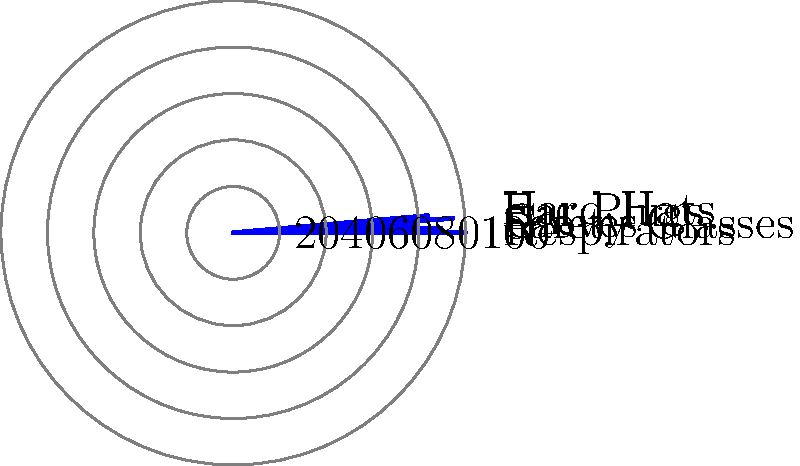Based on the polar bar chart depicting the effectiveness of various personal protective equipment (PPE) types, which PPE item demonstrates the highest effectiveness rating, and what potential implications might this have for worker safety recommendations in high-risk environments? To answer this question, we need to analyze the polar bar chart and interpret its implications for occupational health:

1. Examine the chart:
   The polar bar chart represents five types of PPE: Respirators, Safety Glasses, Gloves, Ear Plugs, and Hard Hats.

2. Identify the highest effectiveness rating:
   The longest bar in the chart corresponds to Respirators, indicating the highest effectiveness rating.

3. Quantify the effectiveness:
   Respirators show an effectiveness rating of approximately 95%.

4. Compare with other PPE:
   - Safety Glasses: ~85%
   - Gloves: ~75%
   - Ear Plugs: ~90%
   - Hard Hats: ~80%

5. Implications for worker safety recommendations:
   a) Respirators should be prioritized in environments with airborne hazards.
   b) The high effectiveness of respirators (95%) suggests they significantly reduce the risk of respiratory issues.
   c) While other PPE items are also important, special emphasis should be placed on proper respirator use and fit-testing.
   d) In high-risk environments with multiple hazards, a comprehensive approach using all PPE types is crucial, with particular attention to respiratory protection.
   e) Training programs should emphasize the critical role of respirators in worker protection.
   f) Occupational health assessments should carefully evaluate the need for respiratory protection in various work settings.

6. Consideration of limitations:
   While respirators show the highest effectiveness, the importance of other PPE should not be overlooked, as they protect against different types of hazards.
Answer: Respirators (95% effective); prioritize in airborne hazard environments, emphasize proper use and fit-testing. 